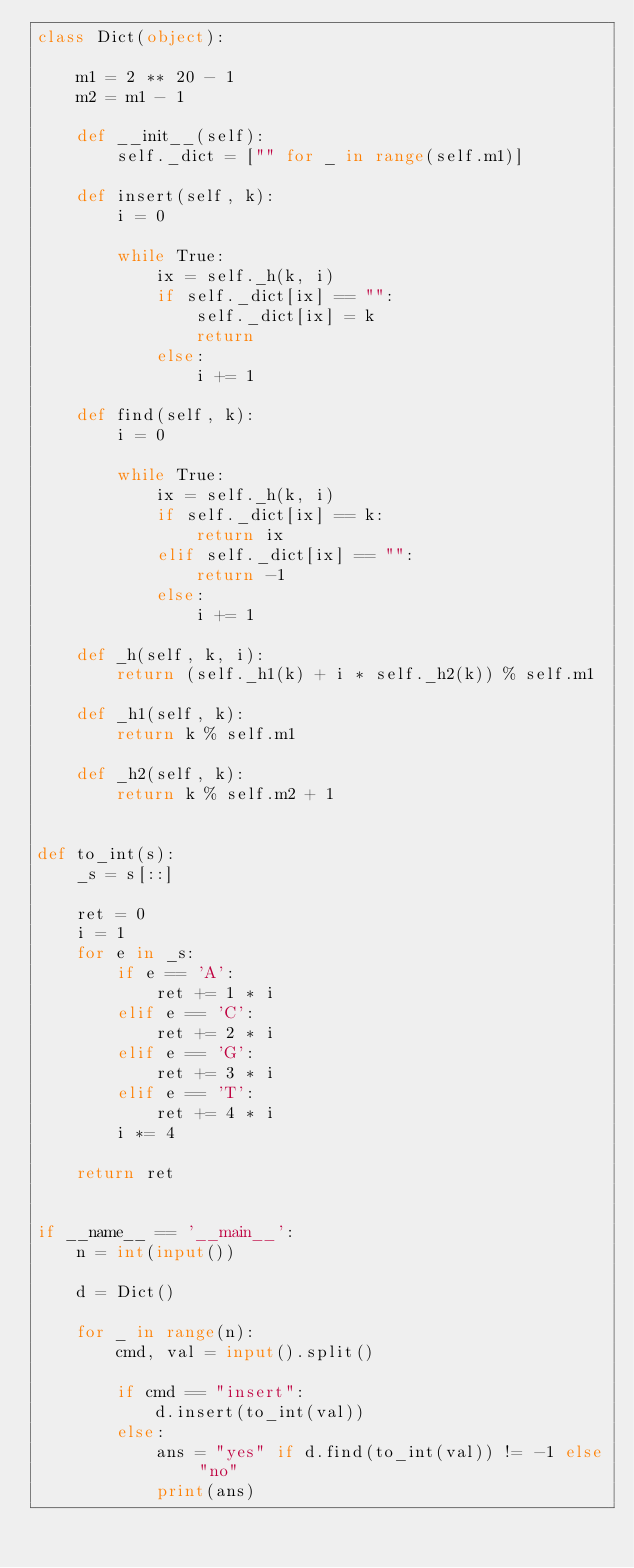Convert code to text. <code><loc_0><loc_0><loc_500><loc_500><_Python_>class Dict(object):

    m1 = 2 ** 20 - 1
    m2 = m1 - 1

    def __init__(self):
        self._dict = ["" for _ in range(self.m1)]

    def insert(self, k):
        i = 0

        while True:
            ix = self._h(k, i)
            if self._dict[ix] == "":
                self._dict[ix] = k
                return
            else:
                i += 1

    def find(self, k):
        i = 0

        while True:
            ix = self._h(k, i)
            if self._dict[ix] == k:
                return ix
            elif self._dict[ix] == "":
                return -1
            else:
                i += 1

    def _h(self, k, i):
        return (self._h1(k) + i * self._h2(k)) % self.m1

    def _h1(self, k):
        return k % self.m1

    def _h2(self, k):
        return k % self.m2 + 1


def to_int(s):
    _s = s[::]

    ret = 0
    i = 1
    for e in _s:
        if e == 'A':
            ret += 1 * i
        elif e == 'C':
            ret += 2 * i
        elif e == 'G':
            ret += 3 * i
        elif e == 'T':
            ret += 4 * i
        i *= 4

    return ret


if __name__ == '__main__':
    n = int(input())

    d = Dict()

    for _ in range(n):
        cmd, val = input().split()

        if cmd == "insert":
            d.insert(to_int(val))
        else:
            ans = "yes" if d.find(to_int(val)) != -1 else "no"
            print(ans)</code> 